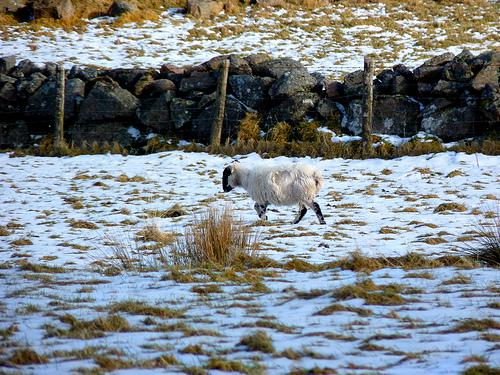Question: what is the goat doing?
Choices:
A. Eating.
B. Laying down.
C. Running.
D. Whining.
Answer with the letter. Answer: C Question: what is on the ground?
Choices:
A. Dirt.
B. Flowers.
C. Snow.
D. Grass.
Answer with the letter. Answer: C Question: why is this wire held up by wood?
Choices:
A. Barbed wire.
B. Telephone wire.
C. Fence.
D. Part of the fence.
Answer with the letter. Answer: C Question: who is in this picture?
Choices:
A. No one.
B. Girlfriend.
C. The dog.
D. A child.
Answer with the letter. Answer: A 